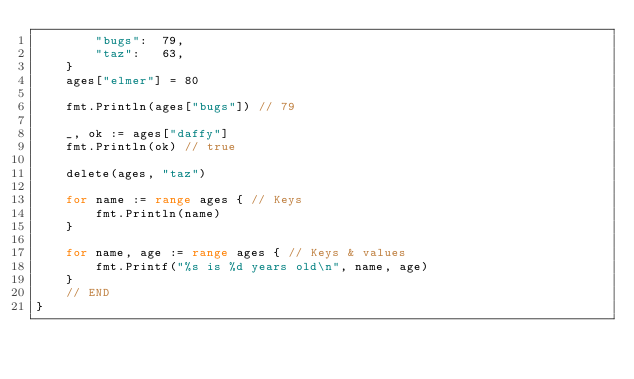Convert code to text. <code><loc_0><loc_0><loc_500><loc_500><_Go_>		"bugs":  79,
		"taz":   63,
	}
	ages["elmer"] = 80

	fmt.Println(ages["bugs"]) // 79

	_, ok := ages["daffy"]
	fmt.Println(ok) // true

	delete(ages, "taz")

	for name := range ages { // Keys
		fmt.Println(name)
	}

	for name, age := range ages { // Keys & values
		fmt.Printf("%s is %d years old\n", name, age)
	}
	// END
}
</code> 